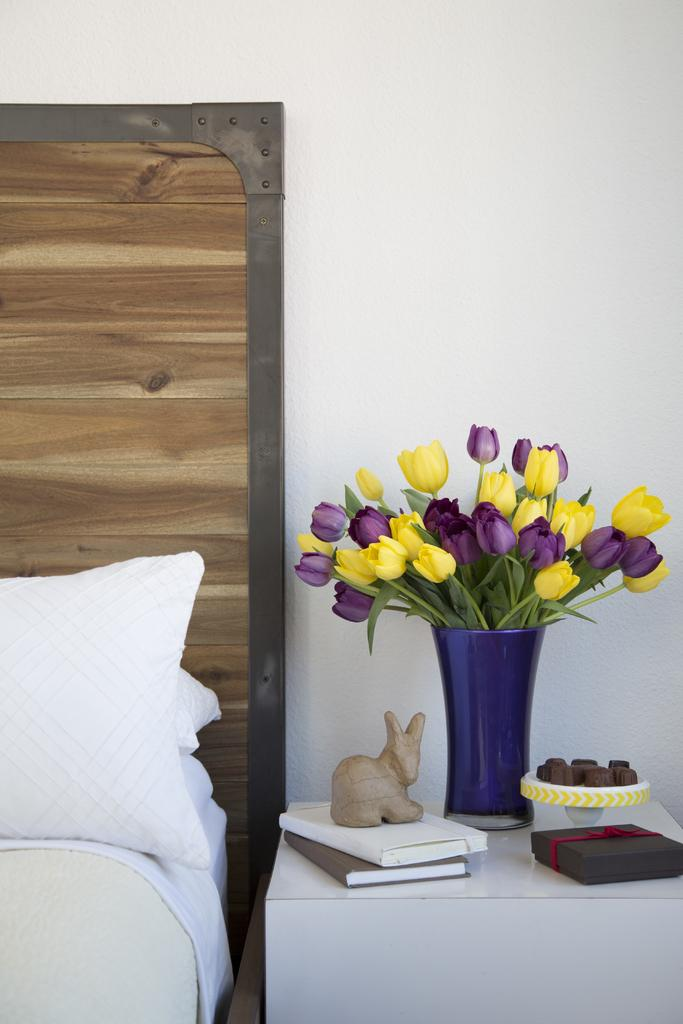What piece of furniture is present in the image? There is a bed in the image. What is placed on the bed? There are pillows and cloth on the bed. What is located near the bed? There is a table in the image. What decorative items can be seen on the table? There are flowers, a vase, a toy, books, and a box on the table. What is visible in the background of the image? There is a wall in the background of the image. How many giants are visible in the image? There are no giants present in the image. What type of stone can be seen on the table? There is no stone visible on the table in the image. 